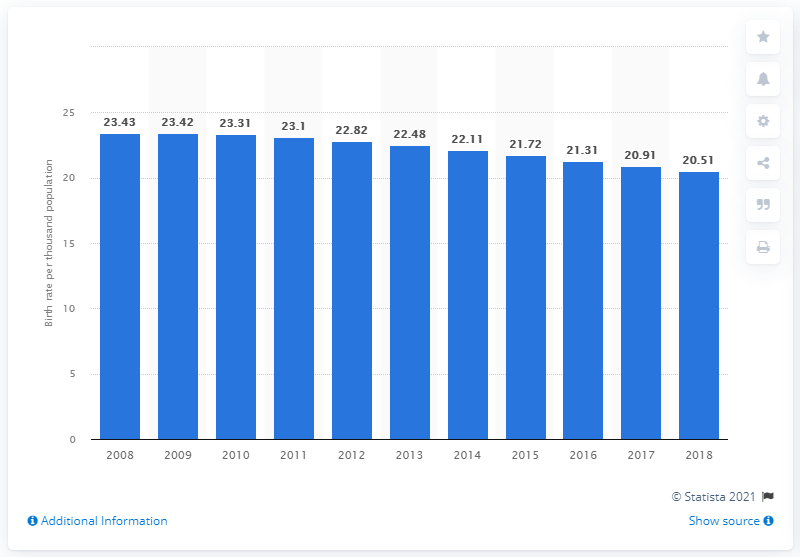List a handful of essential elements in this visual. The crude birth rate in South Africa in 2018 was 20.51. 